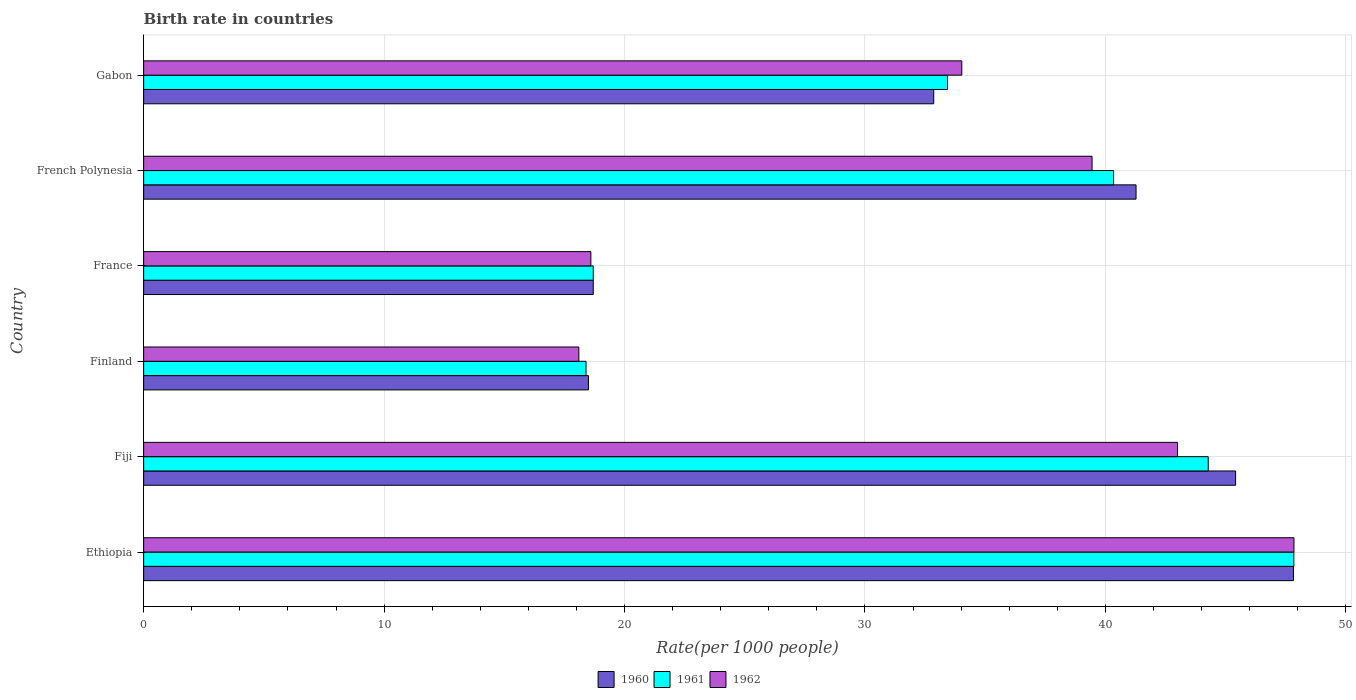What is the label of the 4th group of bars from the top?
Your response must be concise. Finland. In how many cases, is the number of bars for a given country not equal to the number of legend labels?
Give a very brief answer. 0. What is the birth rate in 1960 in Gabon?
Offer a very short reply. 32.86. Across all countries, what is the maximum birth rate in 1961?
Keep it short and to the point. 47.84. In which country was the birth rate in 1961 maximum?
Keep it short and to the point. Ethiopia. In which country was the birth rate in 1961 minimum?
Provide a succinct answer. Finland. What is the total birth rate in 1961 in the graph?
Keep it short and to the point. 202.99. What is the difference between the birth rate in 1961 in Ethiopia and that in Gabon?
Your answer should be compact. 14.4. What is the difference between the birth rate in 1960 in Finland and the birth rate in 1961 in France?
Your answer should be very brief. -0.2. What is the average birth rate in 1961 per country?
Your answer should be compact. 33.83. What is the difference between the birth rate in 1961 and birth rate in 1962 in French Polynesia?
Give a very brief answer. 0.9. In how many countries, is the birth rate in 1960 greater than 22 ?
Provide a succinct answer. 4. What is the ratio of the birth rate in 1961 in Ethiopia to that in Fiji?
Provide a succinct answer. 1.08. Is the birth rate in 1962 in Fiji less than that in France?
Make the answer very short. No. Is the difference between the birth rate in 1961 in Finland and French Polynesia greater than the difference between the birth rate in 1962 in Finland and French Polynesia?
Your response must be concise. No. What is the difference between the highest and the second highest birth rate in 1961?
Provide a succinct answer. 3.56. What is the difference between the highest and the lowest birth rate in 1961?
Ensure brevity in your answer.  29.44. In how many countries, is the birth rate in 1961 greater than the average birth rate in 1961 taken over all countries?
Your answer should be compact. 3. What does the 2nd bar from the bottom in Finland represents?
Provide a short and direct response. 1961. Is it the case that in every country, the sum of the birth rate in 1962 and birth rate in 1960 is greater than the birth rate in 1961?
Your response must be concise. Yes. How many bars are there?
Give a very brief answer. 18. Are all the bars in the graph horizontal?
Offer a very short reply. Yes. How many countries are there in the graph?
Give a very brief answer. 6. Does the graph contain grids?
Ensure brevity in your answer.  Yes. What is the title of the graph?
Provide a short and direct response. Birth rate in countries. What is the label or title of the X-axis?
Provide a succinct answer. Rate(per 1000 people). What is the label or title of the Y-axis?
Ensure brevity in your answer.  Country. What is the Rate(per 1000 people) in 1960 in Ethiopia?
Provide a short and direct response. 47.82. What is the Rate(per 1000 people) in 1961 in Ethiopia?
Offer a terse response. 47.84. What is the Rate(per 1000 people) of 1962 in Ethiopia?
Your response must be concise. 47.84. What is the Rate(per 1000 people) in 1960 in Fiji?
Offer a very short reply. 45.41. What is the Rate(per 1000 people) in 1961 in Fiji?
Your answer should be very brief. 44.28. What is the Rate(per 1000 people) of 1962 in Fiji?
Make the answer very short. 43. What is the Rate(per 1000 people) of 1961 in Finland?
Ensure brevity in your answer.  18.4. What is the Rate(per 1000 people) in 1961 in France?
Give a very brief answer. 18.7. What is the Rate(per 1000 people) in 1962 in France?
Make the answer very short. 18.6. What is the Rate(per 1000 people) of 1960 in French Polynesia?
Your answer should be very brief. 41.27. What is the Rate(per 1000 people) of 1961 in French Polynesia?
Your answer should be compact. 40.34. What is the Rate(per 1000 people) of 1962 in French Polynesia?
Ensure brevity in your answer.  39.45. What is the Rate(per 1000 people) in 1960 in Gabon?
Offer a terse response. 32.86. What is the Rate(per 1000 people) of 1961 in Gabon?
Provide a short and direct response. 33.44. What is the Rate(per 1000 people) of 1962 in Gabon?
Provide a succinct answer. 34.03. Across all countries, what is the maximum Rate(per 1000 people) in 1960?
Make the answer very short. 47.82. Across all countries, what is the maximum Rate(per 1000 people) of 1961?
Keep it short and to the point. 47.84. Across all countries, what is the maximum Rate(per 1000 people) in 1962?
Ensure brevity in your answer.  47.84. Across all countries, what is the minimum Rate(per 1000 people) in 1960?
Provide a short and direct response. 18.5. Across all countries, what is the minimum Rate(per 1000 people) in 1961?
Your answer should be very brief. 18.4. Across all countries, what is the minimum Rate(per 1000 people) in 1962?
Make the answer very short. 18.1. What is the total Rate(per 1000 people) in 1960 in the graph?
Offer a very short reply. 204.57. What is the total Rate(per 1000 people) in 1961 in the graph?
Ensure brevity in your answer.  202.99. What is the total Rate(per 1000 people) in 1962 in the graph?
Offer a terse response. 201.01. What is the difference between the Rate(per 1000 people) in 1960 in Ethiopia and that in Fiji?
Offer a terse response. 2.41. What is the difference between the Rate(per 1000 people) of 1961 in Ethiopia and that in Fiji?
Your answer should be very brief. 3.56. What is the difference between the Rate(per 1000 people) of 1962 in Ethiopia and that in Fiji?
Your answer should be compact. 4.84. What is the difference between the Rate(per 1000 people) in 1960 in Ethiopia and that in Finland?
Make the answer very short. 29.32. What is the difference between the Rate(per 1000 people) of 1961 in Ethiopia and that in Finland?
Ensure brevity in your answer.  29.44. What is the difference between the Rate(per 1000 people) of 1962 in Ethiopia and that in Finland?
Offer a very short reply. 29.74. What is the difference between the Rate(per 1000 people) of 1960 in Ethiopia and that in France?
Ensure brevity in your answer.  29.12. What is the difference between the Rate(per 1000 people) in 1961 in Ethiopia and that in France?
Your answer should be very brief. 29.14. What is the difference between the Rate(per 1000 people) of 1962 in Ethiopia and that in France?
Ensure brevity in your answer.  29.24. What is the difference between the Rate(per 1000 people) in 1960 in Ethiopia and that in French Polynesia?
Provide a short and direct response. 6.55. What is the difference between the Rate(per 1000 people) in 1961 in Ethiopia and that in French Polynesia?
Your answer should be very brief. 7.5. What is the difference between the Rate(per 1000 people) of 1962 in Ethiopia and that in French Polynesia?
Make the answer very short. 8.4. What is the difference between the Rate(per 1000 people) in 1960 in Ethiopia and that in Gabon?
Keep it short and to the point. 14.96. What is the difference between the Rate(per 1000 people) in 1961 in Ethiopia and that in Gabon?
Your answer should be compact. 14.4. What is the difference between the Rate(per 1000 people) in 1962 in Ethiopia and that in Gabon?
Your answer should be compact. 13.82. What is the difference between the Rate(per 1000 people) of 1960 in Fiji and that in Finland?
Make the answer very short. 26.91. What is the difference between the Rate(per 1000 people) in 1961 in Fiji and that in Finland?
Keep it short and to the point. 25.88. What is the difference between the Rate(per 1000 people) in 1962 in Fiji and that in Finland?
Give a very brief answer. 24.9. What is the difference between the Rate(per 1000 people) of 1960 in Fiji and that in France?
Your answer should be very brief. 26.71. What is the difference between the Rate(per 1000 people) of 1961 in Fiji and that in France?
Make the answer very short. 25.58. What is the difference between the Rate(per 1000 people) of 1962 in Fiji and that in France?
Keep it short and to the point. 24.4. What is the difference between the Rate(per 1000 people) in 1960 in Fiji and that in French Polynesia?
Provide a succinct answer. 4.14. What is the difference between the Rate(per 1000 people) of 1961 in Fiji and that in French Polynesia?
Provide a succinct answer. 3.94. What is the difference between the Rate(per 1000 people) of 1962 in Fiji and that in French Polynesia?
Keep it short and to the point. 3.55. What is the difference between the Rate(per 1000 people) of 1960 in Fiji and that in Gabon?
Provide a succinct answer. 12.55. What is the difference between the Rate(per 1000 people) of 1961 in Fiji and that in Gabon?
Offer a terse response. 10.84. What is the difference between the Rate(per 1000 people) of 1962 in Fiji and that in Gabon?
Your response must be concise. 8.97. What is the difference between the Rate(per 1000 people) in 1960 in Finland and that in France?
Give a very brief answer. -0.2. What is the difference between the Rate(per 1000 people) of 1961 in Finland and that in France?
Provide a succinct answer. -0.3. What is the difference between the Rate(per 1000 people) in 1962 in Finland and that in France?
Your answer should be very brief. -0.5. What is the difference between the Rate(per 1000 people) in 1960 in Finland and that in French Polynesia?
Your response must be concise. -22.77. What is the difference between the Rate(per 1000 people) of 1961 in Finland and that in French Polynesia?
Make the answer very short. -21.94. What is the difference between the Rate(per 1000 people) in 1962 in Finland and that in French Polynesia?
Ensure brevity in your answer.  -21.34. What is the difference between the Rate(per 1000 people) in 1960 in Finland and that in Gabon?
Ensure brevity in your answer.  -14.36. What is the difference between the Rate(per 1000 people) in 1961 in Finland and that in Gabon?
Provide a succinct answer. -15.04. What is the difference between the Rate(per 1000 people) of 1962 in Finland and that in Gabon?
Provide a short and direct response. -15.93. What is the difference between the Rate(per 1000 people) of 1960 in France and that in French Polynesia?
Your answer should be compact. -22.57. What is the difference between the Rate(per 1000 people) of 1961 in France and that in French Polynesia?
Give a very brief answer. -21.64. What is the difference between the Rate(per 1000 people) of 1962 in France and that in French Polynesia?
Your answer should be very brief. -20.84. What is the difference between the Rate(per 1000 people) in 1960 in France and that in Gabon?
Keep it short and to the point. -14.16. What is the difference between the Rate(per 1000 people) in 1961 in France and that in Gabon?
Make the answer very short. -14.74. What is the difference between the Rate(per 1000 people) of 1962 in France and that in Gabon?
Make the answer very short. -15.43. What is the difference between the Rate(per 1000 people) in 1960 in French Polynesia and that in Gabon?
Your response must be concise. 8.41. What is the difference between the Rate(per 1000 people) of 1961 in French Polynesia and that in Gabon?
Offer a terse response. 6.91. What is the difference between the Rate(per 1000 people) in 1962 in French Polynesia and that in Gabon?
Keep it short and to the point. 5.42. What is the difference between the Rate(per 1000 people) in 1960 in Ethiopia and the Rate(per 1000 people) in 1961 in Fiji?
Give a very brief answer. 3.54. What is the difference between the Rate(per 1000 people) in 1960 in Ethiopia and the Rate(per 1000 people) in 1962 in Fiji?
Give a very brief answer. 4.82. What is the difference between the Rate(per 1000 people) of 1961 in Ethiopia and the Rate(per 1000 people) of 1962 in Fiji?
Offer a very short reply. 4.84. What is the difference between the Rate(per 1000 people) of 1960 in Ethiopia and the Rate(per 1000 people) of 1961 in Finland?
Make the answer very short. 29.42. What is the difference between the Rate(per 1000 people) in 1960 in Ethiopia and the Rate(per 1000 people) in 1962 in Finland?
Provide a short and direct response. 29.72. What is the difference between the Rate(per 1000 people) in 1961 in Ethiopia and the Rate(per 1000 people) in 1962 in Finland?
Your answer should be very brief. 29.74. What is the difference between the Rate(per 1000 people) of 1960 in Ethiopia and the Rate(per 1000 people) of 1961 in France?
Give a very brief answer. 29.12. What is the difference between the Rate(per 1000 people) of 1960 in Ethiopia and the Rate(per 1000 people) of 1962 in France?
Your response must be concise. 29.22. What is the difference between the Rate(per 1000 people) of 1961 in Ethiopia and the Rate(per 1000 people) of 1962 in France?
Keep it short and to the point. 29.24. What is the difference between the Rate(per 1000 people) of 1960 in Ethiopia and the Rate(per 1000 people) of 1961 in French Polynesia?
Provide a short and direct response. 7.48. What is the difference between the Rate(per 1000 people) in 1960 in Ethiopia and the Rate(per 1000 people) in 1962 in French Polynesia?
Ensure brevity in your answer.  8.38. What is the difference between the Rate(per 1000 people) in 1961 in Ethiopia and the Rate(per 1000 people) in 1962 in French Polynesia?
Keep it short and to the point. 8.39. What is the difference between the Rate(per 1000 people) in 1960 in Ethiopia and the Rate(per 1000 people) in 1961 in Gabon?
Your answer should be compact. 14.38. What is the difference between the Rate(per 1000 people) of 1960 in Ethiopia and the Rate(per 1000 people) of 1962 in Gabon?
Make the answer very short. 13.79. What is the difference between the Rate(per 1000 people) in 1961 in Ethiopia and the Rate(per 1000 people) in 1962 in Gabon?
Provide a short and direct response. 13.81. What is the difference between the Rate(per 1000 people) in 1960 in Fiji and the Rate(per 1000 people) in 1961 in Finland?
Give a very brief answer. 27.02. What is the difference between the Rate(per 1000 people) of 1960 in Fiji and the Rate(per 1000 people) of 1962 in Finland?
Make the answer very short. 27.32. What is the difference between the Rate(per 1000 people) of 1961 in Fiji and the Rate(per 1000 people) of 1962 in Finland?
Offer a very short reply. 26.18. What is the difference between the Rate(per 1000 people) in 1960 in Fiji and the Rate(per 1000 people) in 1961 in France?
Offer a terse response. 26.71. What is the difference between the Rate(per 1000 people) of 1960 in Fiji and the Rate(per 1000 people) of 1962 in France?
Provide a succinct answer. 26.82. What is the difference between the Rate(per 1000 people) in 1961 in Fiji and the Rate(per 1000 people) in 1962 in France?
Your response must be concise. 25.68. What is the difference between the Rate(per 1000 people) of 1960 in Fiji and the Rate(per 1000 people) of 1961 in French Polynesia?
Make the answer very short. 5.07. What is the difference between the Rate(per 1000 people) of 1960 in Fiji and the Rate(per 1000 people) of 1962 in French Polynesia?
Offer a terse response. 5.97. What is the difference between the Rate(per 1000 people) of 1961 in Fiji and the Rate(per 1000 people) of 1962 in French Polynesia?
Make the answer very short. 4.83. What is the difference between the Rate(per 1000 people) in 1960 in Fiji and the Rate(per 1000 people) in 1961 in Gabon?
Ensure brevity in your answer.  11.98. What is the difference between the Rate(per 1000 people) in 1960 in Fiji and the Rate(per 1000 people) in 1962 in Gabon?
Offer a terse response. 11.39. What is the difference between the Rate(per 1000 people) of 1961 in Fiji and the Rate(per 1000 people) of 1962 in Gabon?
Your answer should be very brief. 10.25. What is the difference between the Rate(per 1000 people) in 1960 in Finland and the Rate(per 1000 people) in 1961 in France?
Your answer should be very brief. -0.2. What is the difference between the Rate(per 1000 people) of 1960 in Finland and the Rate(per 1000 people) of 1962 in France?
Offer a very short reply. -0.1. What is the difference between the Rate(per 1000 people) of 1960 in Finland and the Rate(per 1000 people) of 1961 in French Polynesia?
Provide a succinct answer. -21.84. What is the difference between the Rate(per 1000 people) in 1960 in Finland and the Rate(per 1000 people) in 1962 in French Polynesia?
Provide a short and direct response. -20.95. What is the difference between the Rate(per 1000 people) of 1961 in Finland and the Rate(per 1000 people) of 1962 in French Polynesia?
Give a very brief answer. -21.05. What is the difference between the Rate(per 1000 people) in 1960 in Finland and the Rate(per 1000 people) in 1961 in Gabon?
Make the answer very short. -14.94. What is the difference between the Rate(per 1000 people) in 1960 in Finland and the Rate(per 1000 people) in 1962 in Gabon?
Your answer should be compact. -15.53. What is the difference between the Rate(per 1000 people) of 1961 in Finland and the Rate(per 1000 people) of 1962 in Gabon?
Your answer should be compact. -15.63. What is the difference between the Rate(per 1000 people) of 1960 in France and the Rate(per 1000 people) of 1961 in French Polynesia?
Offer a terse response. -21.64. What is the difference between the Rate(per 1000 people) of 1960 in France and the Rate(per 1000 people) of 1962 in French Polynesia?
Ensure brevity in your answer.  -20.75. What is the difference between the Rate(per 1000 people) in 1961 in France and the Rate(per 1000 people) in 1962 in French Polynesia?
Offer a terse response. -20.75. What is the difference between the Rate(per 1000 people) in 1960 in France and the Rate(per 1000 people) in 1961 in Gabon?
Make the answer very short. -14.74. What is the difference between the Rate(per 1000 people) in 1960 in France and the Rate(per 1000 people) in 1962 in Gabon?
Your response must be concise. -15.33. What is the difference between the Rate(per 1000 people) of 1961 in France and the Rate(per 1000 people) of 1962 in Gabon?
Ensure brevity in your answer.  -15.33. What is the difference between the Rate(per 1000 people) in 1960 in French Polynesia and the Rate(per 1000 people) in 1961 in Gabon?
Your answer should be very brief. 7.84. What is the difference between the Rate(per 1000 people) of 1960 in French Polynesia and the Rate(per 1000 people) of 1962 in Gabon?
Provide a short and direct response. 7.25. What is the difference between the Rate(per 1000 people) in 1961 in French Polynesia and the Rate(per 1000 people) in 1962 in Gabon?
Provide a succinct answer. 6.32. What is the average Rate(per 1000 people) of 1960 per country?
Provide a succinct answer. 34.1. What is the average Rate(per 1000 people) in 1961 per country?
Offer a very short reply. 33.83. What is the average Rate(per 1000 people) of 1962 per country?
Your answer should be compact. 33.5. What is the difference between the Rate(per 1000 people) of 1960 and Rate(per 1000 people) of 1961 in Ethiopia?
Your answer should be compact. -0.02. What is the difference between the Rate(per 1000 people) of 1960 and Rate(per 1000 people) of 1962 in Ethiopia?
Provide a short and direct response. -0.02. What is the difference between the Rate(per 1000 people) in 1961 and Rate(per 1000 people) in 1962 in Ethiopia?
Ensure brevity in your answer.  -0.01. What is the difference between the Rate(per 1000 people) of 1960 and Rate(per 1000 people) of 1961 in Fiji?
Keep it short and to the point. 1.14. What is the difference between the Rate(per 1000 people) of 1960 and Rate(per 1000 people) of 1962 in Fiji?
Ensure brevity in your answer.  2.42. What is the difference between the Rate(per 1000 people) in 1961 and Rate(per 1000 people) in 1962 in Fiji?
Your answer should be very brief. 1.28. What is the difference between the Rate(per 1000 people) of 1960 and Rate(per 1000 people) of 1961 in Finland?
Your answer should be compact. 0.1. What is the difference between the Rate(per 1000 people) of 1960 and Rate(per 1000 people) of 1962 in Finland?
Ensure brevity in your answer.  0.4. What is the difference between the Rate(per 1000 people) of 1961 and Rate(per 1000 people) of 1962 in Finland?
Your response must be concise. 0.3. What is the difference between the Rate(per 1000 people) of 1960 and Rate(per 1000 people) of 1962 in France?
Provide a short and direct response. 0.1. What is the difference between the Rate(per 1000 people) of 1961 and Rate(per 1000 people) of 1962 in France?
Keep it short and to the point. 0.1. What is the difference between the Rate(per 1000 people) in 1960 and Rate(per 1000 people) in 1961 in French Polynesia?
Offer a very short reply. 0.93. What is the difference between the Rate(per 1000 people) of 1960 and Rate(per 1000 people) of 1962 in French Polynesia?
Provide a short and direct response. 1.83. What is the difference between the Rate(per 1000 people) in 1961 and Rate(per 1000 people) in 1962 in French Polynesia?
Offer a terse response. 0.9. What is the difference between the Rate(per 1000 people) of 1960 and Rate(per 1000 people) of 1961 in Gabon?
Give a very brief answer. -0.58. What is the difference between the Rate(per 1000 people) of 1960 and Rate(per 1000 people) of 1962 in Gabon?
Provide a succinct answer. -1.17. What is the difference between the Rate(per 1000 people) in 1961 and Rate(per 1000 people) in 1962 in Gabon?
Keep it short and to the point. -0.59. What is the ratio of the Rate(per 1000 people) in 1960 in Ethiopia to that in Fiji?
Your answer should be very brief. 1.05. What is the ratio of the Rate(per 1000 people) of 1961 in Ethiopia to that in Fiji?
Give a very brief answer. 1.08. What is the ratio of the Rate(per 1000 people) of 1962 in Ethiopia to that in Fiji?
Keep it short and to the point. 1.11. What is the ratio of the Rate(per 1000 people) of 1960 in Ethiopia to that in Finland?
Provide a short and direct response. 2.58. What is the ratio of the Rate(per 1000 people) in 1961 in Ethiopia to that in Finland?
Your response must be concise. 2.6. What is the ratio of the Rate(per 1000 people) of 1962 in Ethiopia to that in Finland?
Make the answer very short. 2.64. What is the ratio of the Rate(per 1000 people) in 1960 in Ethiopia to that in France?
Offer a terse response. 2.56. What is the ratio of the Rate(per 1000 people) of 1961 in Ethiopia to that in France?
Offer a terse response. 2.56. What is the ratio of the Rate(per 1000 people) in 1962 in Ethiopia to that in France?
Keep it short and to the point. 2.57. What is the ratio of the Rate(per 1000 people) in 1960 in Ethiopia to that in French Polynesia?
Give a very brief answer. 1.16. What is the ratio of the Rate(per 1000 people) in 1961 in Ethiopia to that in French Polynesia?
Offer a very short reply. 1.19. What is the ratio of the Rate(per 1000 people) of 1962 in Ethiopia to that in French Polynesia?
Keep it short and to the point. 1.21. What is the ratio of the Rate(per 1000 people) of 1960 in Ethiopia to that in Gabon?
Provide a short and direct response. 1.46. What is the ratio of the Rate(per 1000 people) of 1961 in Ethiopia to that in Gabon?
Make the answer very short. 1.43. What is the ratio of the Rate(per 1000 people) in 1962 in Ethiopia to that in Gabon?
Your answer should be compact. 1.41. What is the ratio of the Rate(per 1000 people) in 1960 in Fiji to that in Finland?
Offer a very short reply. 2.45. What is the ratio of the Rate(per 1000 people) of 1961 in Fiji to that in Finland?
Keep it short and to the point. 2.41. What is the ratio of the Rate(per 1000 people) of 1962 in Fiji to that in Finland?
Your response must be concise. 2.38. What is the ratio of the Rate(per 1000 people) in 1960 in Fiji to that in France?
Ensure brevity in your answer.  2.43. What is the ratio of the Rate(per 1000 people) in 1961 in Fiji to that in France?
Offer a terse response. 2.37. What is the ratio of the Rate(per 1000 people) of 1962 in Fiji to that in France?
Provide a succinct answer. 2.31. What is the ratio of the Rate(per 1000 people) of 1960 in Fiji to that in French Polynesia?
Provide a short and direct response. 1.1. What is the ratio of the Rate(per 1000 people) of 1961 in Fiji to that in French Polynesia?
Ensure brevity in your answer.  1.1. What is the ratio of the Rate(per 1000 people) of 1962 in Fiji to that in French Polynesia?
Keep it short and to the point. 1.09. What is the ratio of the Rate(per 1000 people) in 1960 in Fiji to that in Gabon?
Offer a terse response. 1.38. What is the ratio of the Rate(per 1000 people) in 1961 in Fiji to that in Gabon?
Provide a short and direct response. 1.32. What is the ratio of the Rate(per 1000 people) of 1962 in Fiji to that in Gabon?
Provide a short and direct response. 1.26. What is the ratio of the Rate(per 1000 people) of 1960 in Finland to that in France?
Provide a short and direct response. 0.99. What is the ratio of the Rate(per 1000 people) in 1962 in Finland to that in France?
Give a very brief answer. 0.97. What is the ratio of the Rate(per 1000 people) in 1960 in Finland to that in French Polynesia?
Offer a terse response. 0.45. What is the ratio of the Rate(per 1000 people) in 1961 in Finland to that in French Polynesia?
Give a very brief answer. 0.46. What is the ratio of the Rate(per 1000 people) of 1962 in Finland to that in French Polynesia?
Offer a very short reply. 0.46. What is the ratio of the Rate(per 1000 people) in 1960 in Finland to that in Gabon?
Keep it short and to the point. 0.56. What is the ratio of the Rate(per 1000 people) in 1961 in Finland to that in Gabon?
Offer a terse response. 0.55. What is the ratio of the Rate(per 1000 people) in 1962 in Finland to that in Gabon?
Your answer should be compact. 0.53. What is the ratio of the Rate(per 1000 people) of 1960 in France to that in French Polynesia?
Your response must be concise. 0.45. What is the ratio of the Rate(per 1000 people) of 1961 in France to that in French Polynesia?
Offer a terse response. 0.46. What is the ratio of the Rate(per 1000 people) of 1962 in France to that in French Polynesia?
Offer a very short reply. 0.47. What is the ratio of the Rate(per 1000 people) of 1960 in France to that in Gabon?
Offer a very short reply. 0.57. What is the ratio of the Rate(per 1000 people) in 1961 in France to that in Gabon?
Ensure brevity in your answer.  0.56. What is the ratio of the Rate(per 1000 people) of 1962 in France to that in Gabon?
Ensure brevity in your answer.  0.55. What is the ratio of the Rate(per 1000 people) in 1960 in French Polynesia to that in Gabon?
Ensure brevity in your answer.  1.26. What is the ratio of the Rate(per 1000 people) of 1961 in French Polynesia to that in Gabon?
Give a very brief answer. 1.21. What is the ratio of the Rate(per 1000 people) of 1962 in French Polynesia to that in Gabon?
Your answer should be very brief. 1.16. What is the difference between the highest and the second highest Rate(per 1000 people) in 1960?
Your answer should be compact. 2.41. What is the difference between the highest and the second highest Rate(per 1000 people) in 1961?
Make the answer very short. 3.56. What is the difference between the highest and the second highest Rate(per 1000 people) of 1962?
Your answer should be compact. 4.84. What is the difference between the highest and the lowest Rate(per 1000 people) of 1960?
Provide a short and direct response. 29.32. What is the difference between the highest and the lowest Rate(per 1000 people) in 1961?
Your response must be concise. 29.44. What is the difference between the highest and the lowest Rate(per 1000 people) in 1962?
Provide a short and direct response. 29.74. 